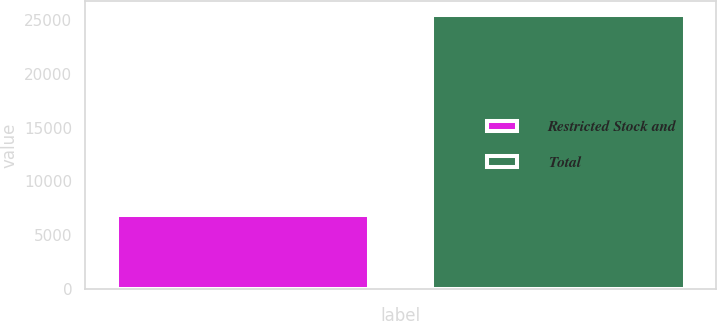<chart> <loc_0><loc_0><loc_500><loc_500><bar_chart><fcel>Restricted Stock and<fcel>Total<nl><fcel>6820<fcel>25495<nl></chart> 